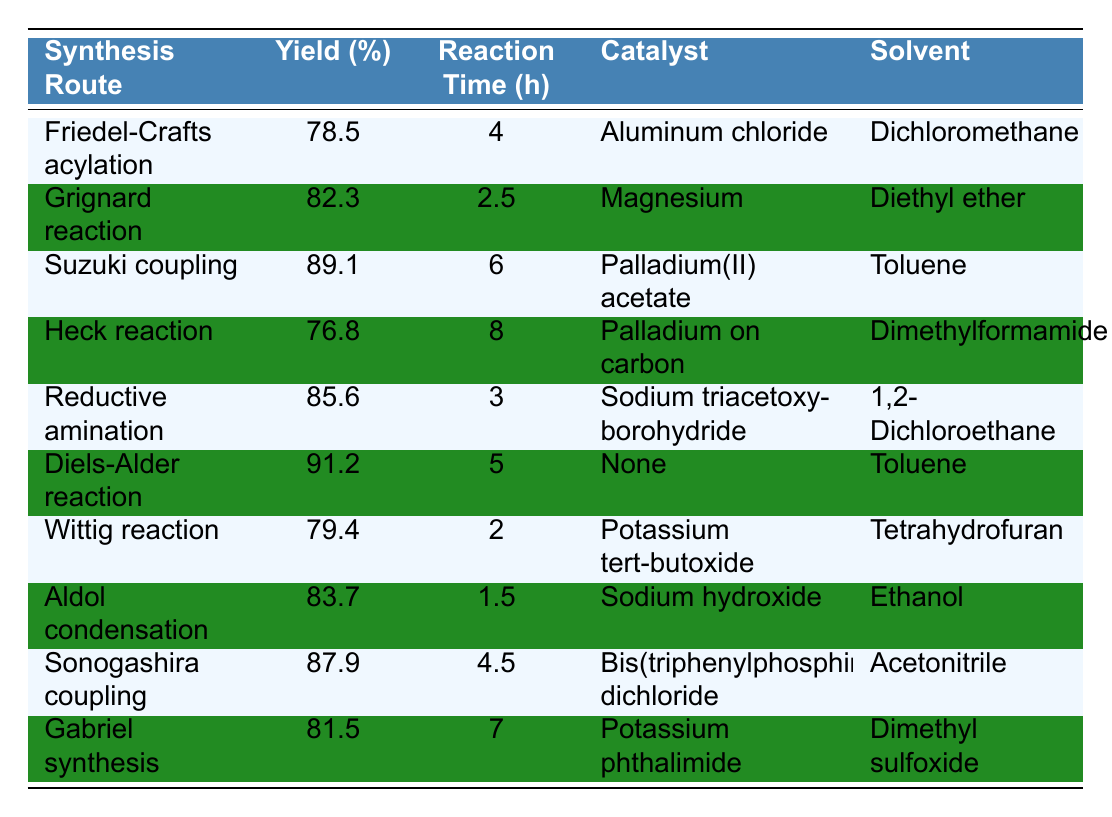What is the highest yield percentage among the synthesis routes? The synthesis routes are listed along with their corresponding yield percentages. By examining the values, the highest yield percentage is associated with the "Diels-Alder reaction," which has a yield of 91.2%.
Answer: 91.2% Which synthesis route has the shortest reaction time? The table lists the reaction times for each synthesis route. The shortest time listed is 1.5 hours for the "Aldol condensation."
Answer: 1.5 hours Is the yield percentage for the "Heck reaction" greater than that of the "Friedel-Crafts acylation"? The yield for the "Heck reaction" is 76.8%, while the "Friedel-Crafts acylation" has a yield of 78.5%. Since 76.8% is less than 78.5%, the statement is false.
Answer: No What is the average yield percentage of the synthesis routes involving palladium as a catalyst? The synthesis routes that use palladium are "Suzuki coupling" (89.1%), "Heck reaction" (76.8%), and "Sonogashira coupling" (87.9%). The average yield is calculated as (89.1 + 76.8 + 87.9)/3 = 251.8/3 = 83.93%.
Answer: 83.93% How many synthesis routes have a yield percentage above 80%? The table shows the yield percentages for each route. The routes with yields above 80% are "Grignard reaction" (82.3%), "Suzuki coupling" (89.1%), "Reductive amination" (85.6%), "Diels-Alder reaction" (91.2%), "Sonogashira coupling" (87.9%), and "Gabriel synthesis" (81.5%). Counting these gives us 6 routes.
Answer: 6 Which solvent corresponds to the "Wittig reaction," and what is its yield percentage? The "Wittig reaction" has "Tetrahydrofuran" listed as its solvent, and its yield percentage is 79.4%.
Answer: Tetrahydrofuran, 79.4% Is there a synthesis route that achieved a yield of exactly 80%? Reviewing the yield percentages listed, no route shows a yield of exactly 80%. The closest values are above and below this number, so the statement is false.
Answer: No What is the difference in yield percentage between the "Diels-Alder reaction" and the "Aldol condensation"? The yield for "Diels-Alder reaction" is 91.2%, and for "Aldol condensation," it is 83.7%. The difference is calculated as 91.2% - 83.7% = 7.5%.
Answer: 7.5% Which catalyst is used in the "Reductive amination"? The catalyst listed for "Reductive amination" is "Sodium triacetoxyborohydride."
Answer: Sodium triacetoxyborohydride How many synthesis routes are performed with a reaction time of 4 hours or longer? Examining the reaction times, the routes "Friedel-Crafts acylation" (4 hours), "Suzuki coupling" (6 hours), "Heck reaction" (8 hours), "Gabriel synthesis" (7 hours), and "Sonogashira coupling" (4.5 hours) are 4 or more hours long, totaling 5 routes.
Answer: 5 Which synthesis route has the second highest yield percentage and what is its value? The highest yield is from "Diels-Alder reaction" at 91.2%. The second highest is "Suzuki coupling" with a yield of 89.1%.
Answer: 89.1% 